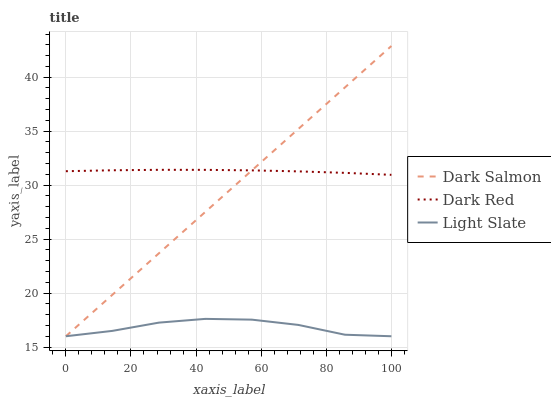Does Light Slate have the minimum area under the curve?
Answer yes or no. Yes. Does Dark Red have the maximum area under the curve?
Answer yes or no. Yes. Does Dark Salmon have the minimum area under the curve?
Answer yes or no. No. Does Dark Salmon have the maximum area under the curve?
Answer yes or no. No. Is Dark Salmon the smoothest?
Answer yes or no. Yes. Is Light Slate the roughest?
Answer yes or no. Yes. Is Dark Red the smoothest?
Answer yes or no. No. Is Dark Red the roughest?
Answer yes or no. No. Does Light Slate have the lowest value?
Answer yes or no. Yes. Does Dark Red have the lowest value?
Answer yes or no. No. Does Dark Salmon have the highest value?
Answer yes or no. Yes. Does Dark Red have the highest value?
Answer yes or no. No. Is Light Slate less than Dark Red?
Answer yes or no. Yes. Is Dark Red greater than Light Slate?
Answer yes or no. Yes. Does Dark Red intersect Dark Salmon?
Answer yes or no. Yes. Is Dark Red less than Dark Salmon?
Answer yes or no. No. Is Dark Red greater than Dark Salmon?
Answer yes or no. No. Does Light Slate intersect Dark Red?
Answer yes or no. No. 